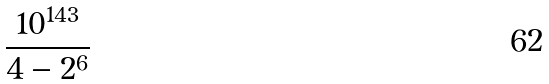<formula> <loc_0><loc_0><loc_500><loc_500>\frac { 1 0 ^ { 1 4 3 } } { 4 - 2 ^ { 6 } }</formula> 